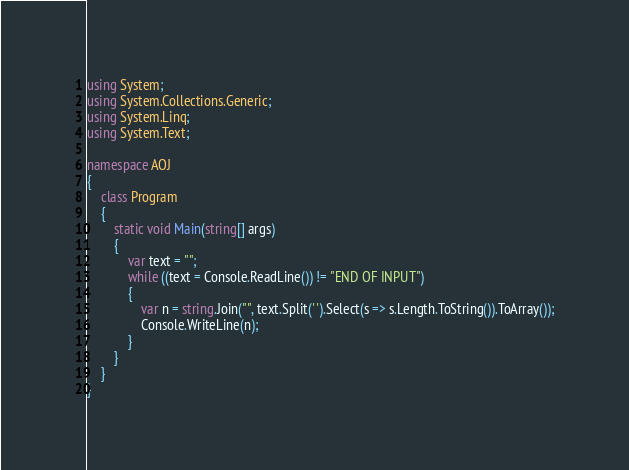Convert code to text. <code><loc_0><loc_0><loc_500><loc_500><_C#_>using System;
using System.Collections.Generic;
using System.Linq;
using System.Text;

namespace AOJ
{
	class Program
	{
		static void Main(string[] args)
		{
			var text = "";
			while ((text = Console.ReadLine()) != "END OF INPUT")
			{
				var n = string.Join("", text.Split(' ').Select(s => s.Length.ToString()).ToArray());
				Console.WriteLine(n);
			}
		}
	}
}</code> 